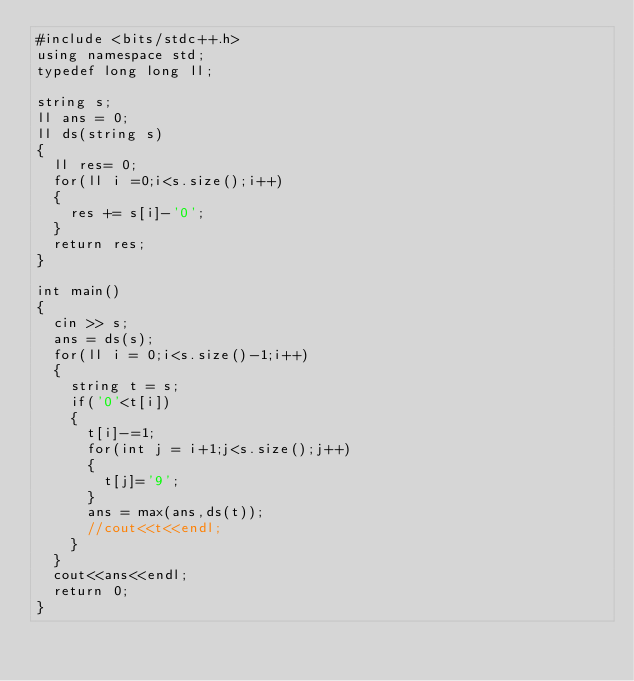Convert code to text. <code><loc_0><loc_0><loc_500><loc_500><_C++_>#include <bits/stdc++.h>
using namespace std;
typedef long long ll;

string s;
ll ans = 0;
ll ds(string s)
{
	ll res= 0;
	for(ll i =0;i<s.size();i++)
	{
		res += s[i]-'0';
	}
	return res;
}

int main()
{
	cin >> s;
	ans = ds(s);
	for(ll i = 0;i<s.size()-1;i++)
	{
		string t = s;
		if('0'<t[i])
		{
			t[i]-=1;
			for(int j = i+1;j<s.size();j++)
			{
				t[j]='9';
			}
			ans = max(ans,ds(t));
			//cout<<t<<endl;
		}
	}
	cout<<ans<<endl;
	return 0;
}</code> 